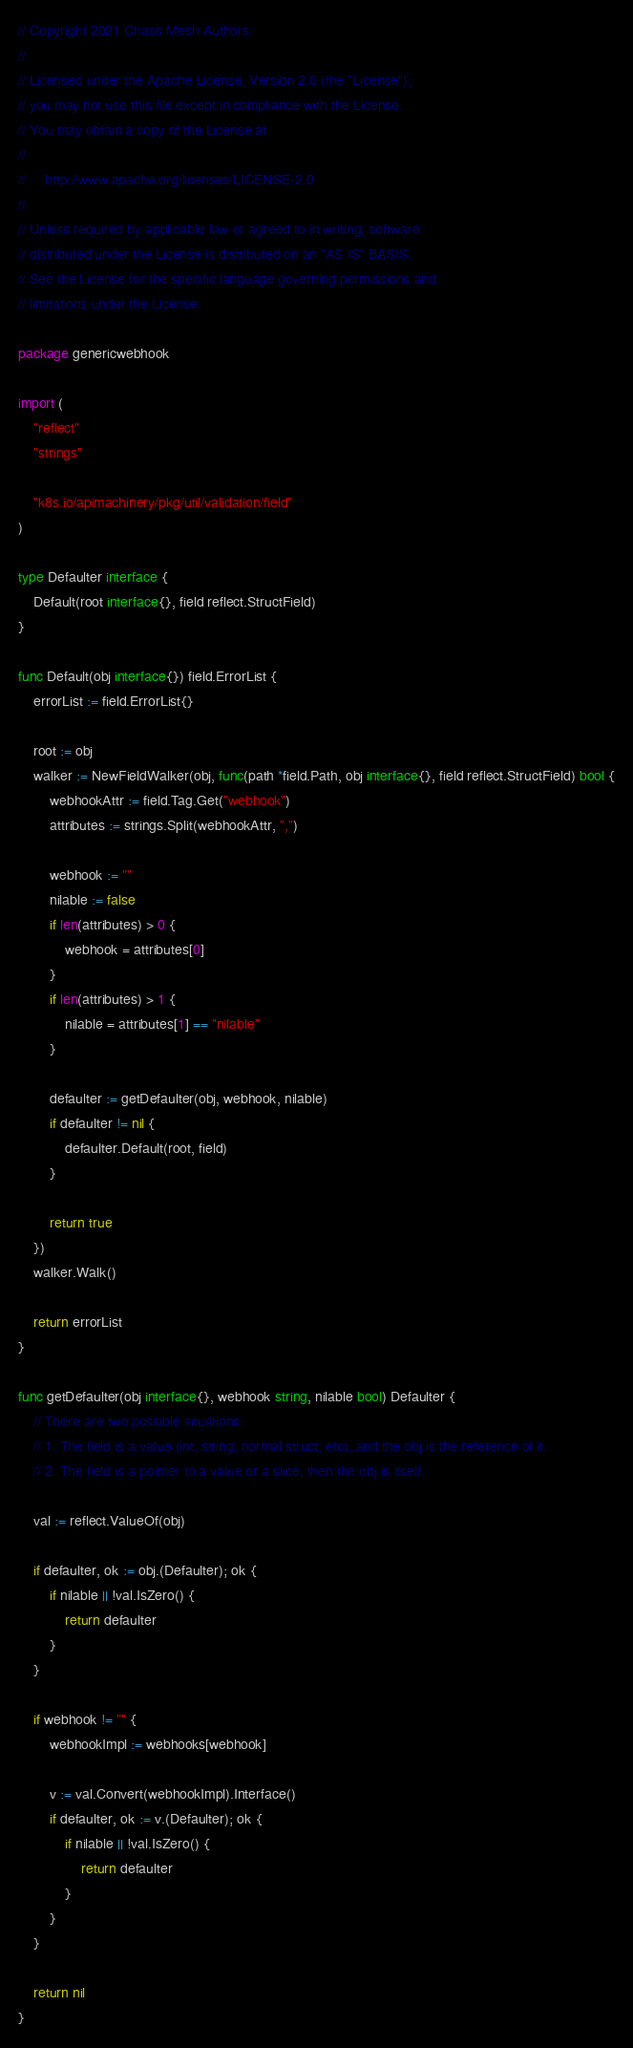Convert code to text. <code><loc_0><loc_0><loc_500><loc_500><_Go_>// Copyright 2021 Chaos Mesh Authors.
//
// Licensed under the Apache License, Version 2.0 (the "License");
// you may not use this file except in compliance with the License.
// You may obtain a copy of the License at
//
//     http://www.apache.org/licenses/LICENSE-2.0
//
// Unless required by applicable law or agreed to in writing, software
// distributed under the License is distributed on an "AS IS" BASIS,
// See the License for the specific language governing permissions and
// limitations under the License.

package genericwebhook

import (
	"reflect"
	"strings"

	"k8s.io/apimachinery/pkg/util/validation/field"
)

type Defaulter interface {
	Default(root interface{}, field reflect.StructField)
}

func Default(obj interface{}) field.ErrorList {
	errorList := field.ErrorList{}

	root := obj
	walker := NewFieldWalker(obj, func(path *field.Path, obj interface{}, field reflect.StructField) bool {
		webhookAttr := field.Tag.Get("webhook")
		attributes := strings.Split(webhookAttr, ",")

		webhook := ""
		nilable := false
		if len(attributes) > 0 {
			webhook = attributes[0]
		}
		if len(attributes) > 1 {
			nilable = attributes[1] == "nilable"
		}

		defaulter := getDefaulter(obj, webhook, nilable)
		if defaulter != nil {
			defaulter.Default(root, field)
		}

		return true
	})
	walker.Walk()

	return errorList
}

func getDefaulter(obj interface{}, webhook string, nilable bool) Defaulter {
	// There are two possible situations:
	// 1. The field is a value (int, string, normal struct, etc), and the obj is the reference of it.
	// 2. The field is a pointer to a value or a slice, then the obj is itself.

	val := reflect.ValueOf(obj)

	if defaulter, ok := obj.(Defaulter); ok {
		if nilable || !val.IsZero() {
			return defaulter
		}
	}

	if webhook != "" {
		webhookImpl := webhooks[webhook]

		v := val.Convert(webhookImpl).Interface()
		if defaulter, ok := v.(Defaulter); ok {
			if nilable || !val.IsZero() {
				return defaulter
			}
		}
	}

	return nil
}
</code> 